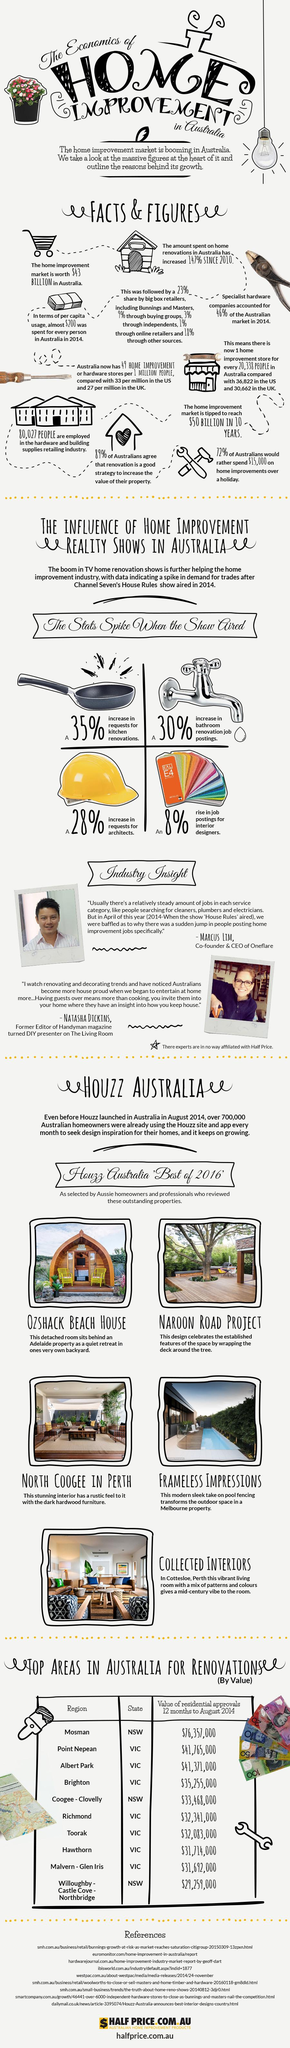Identify some key points in this picture. A majority of Australians, at 72%, are more interested in putting more money towards home decor than vacations. The demand for engineers has risen by 28%. Albert Park is ranked in the top 3 among areas in Australia in terms of residential worth and revamping. According to a recent survey, an overwhelming 89% of Australians believe that the restoration of their home can enhance its value. The second and third residential values in the state of New South Wales (NSW) are 42,09,000 and 48,45,000 respectively. 